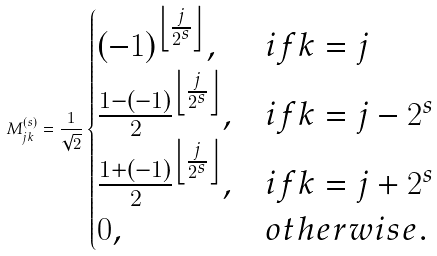Convert formula to latex. <formula><loc_0><loc_0><loc_500><loc_500>M ^ { ( s ) } _ { j k } = \frac { 1 } { \sqrt { 2 } } \begin{cases} ( - 1 ) ^ { \left \lfloor \frac { j } { 2 ^ { s } } \right \rfloor } , & i f k = j \\ \frac { 1 - ( - 1 ) } { 2 } ^ { \left \lfloor \frac { j } { 2 ^ { s } } \right \rfloor } , & i f k = j - 2 ^ { s } \\ \frac { 1 + ( - 1 ) } { 2 } ^ { \left \lfloor \frac { j } { 2 ^ { s } } \right \rfloor } , & i f k = j + 2 ^ { s } \\ 0 , & o t h e r w i s e . \end{cases}</formula> 